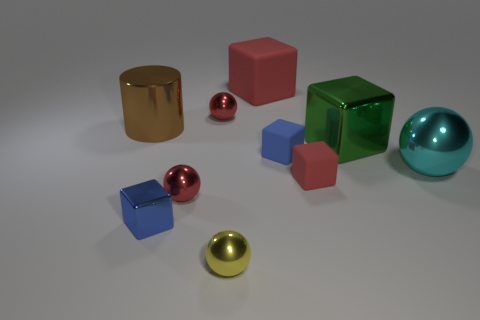What is the shape of the tiny rubber thing that is the same color as the large matte thing?
Offer a very short reply. Cube. What shape is the cyan thing that is the same size as the brown cylinder?
Your answer should be compact. Sphere. Are there any matte objects that have the same color as the tiny metallic cube?
Offer a terse response. Yes. Are there an equal number of big green blocks on the left side of the small red rubber thing and cyan objects in front of the big cylinder?
Ensure brevity in your answer.  No. There is a small yellow shiny thing; is it the same shape as the metal thing that is on the right side of the big shiny cube?
Your answer should be very brief. Yes. What number of other objects are there of the same material as the brown thing?
Your response must be concise. 6. There is a green metal cube; are there any metal things in front of it?
Offer a very short reply. Yes. Does the cyan metallic thing have the same size as the shiny sphere that is in front of the small metal cube?
Your answer should be very brief. No. There is a ball that is on the right side of the red cube that is in front of the large cyan metal sphere; what is its color?
Provide a short and direct response. Cyan. Is the size of the green metallic cube the same as the blue metal block?
Your answer should be very brief. No. 